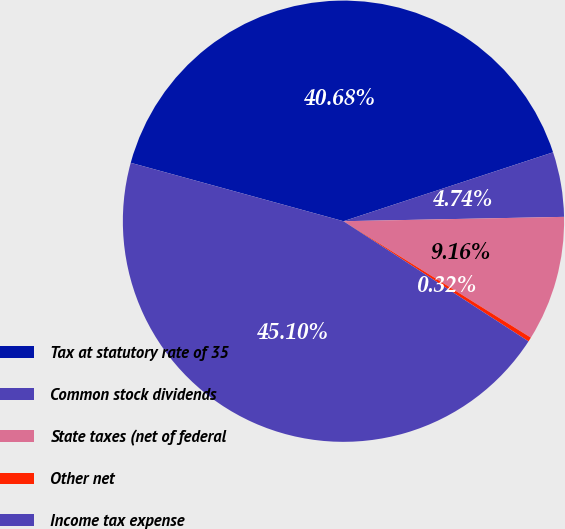Convert chart to OTSL. <chart><loc_0><loc_0><loc_500><loc_500><pie_chart><fcel>Tax at statutory rate of 35<fcel>Common stock dividends<fcel>State taxes (net of federal<fcel>Other net<fcel>Income tax expense<nl><fcel>40.68%<fcel>4.74%<fcel>9.16%<fcel>0.32%<fcel>45.1%<nl></chart> 